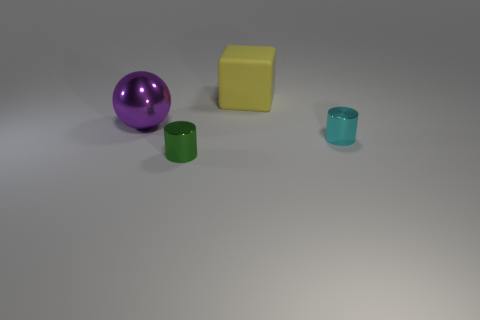Are the cyan cylinder and the big ball made of the same material?
Your response must be concise. Yes. There is a metal object that is behind the tiny green cylinder and to the left of the small cyan metallic cylinder; what is its size?
Offer a terse response. Large. What number of green matte cylinders have the same size as the block?
Ensure brevity in your answer.  0. What size is the metal cylinder right of the tiny thing in front of the small cyan metal object?
Your response must be concise. Small. Do the small object behind the green metallic cylinder and the small object left of the rubber cube have the same shape?
Your answer should be very brief. Yes. What color is the shiny object that is behind the tiny green shiny cylinder and on the right side of the large metallic object?
Ensure brevity in your answer.  Cyan. What color is the big thing right of the green object?
Make the answer very short. Yellow. There is a tiny object right of the large yellow object; are there any big cubes that are behind it?
Your response must be concise. Yes. Are there any large gray balls made of the same material as the big yellow cube?
Your response must be concise. No. How many shiny things are there?
Provide a short and direct response. 3. 